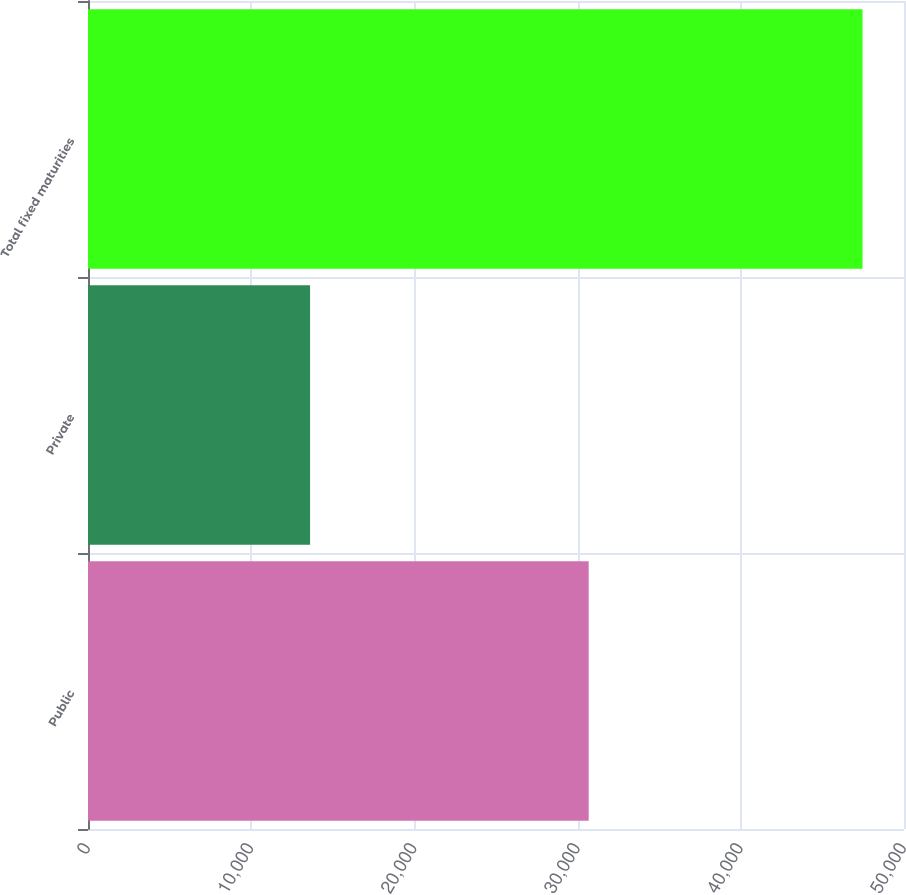Convert chart. <chart><loc_0><loc_0><loc_500><loc_500><bar_chart><fcel>Public<fcel>Private<fcel>Total fixed maturities<nl><fcel>30678.6<fcel>13606.7<fcel>47458.4<nl></chart> 